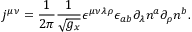<formula> <loc_0><loc_0><loc_500><loc_500>j ^ { \mu \nu } = \frac { 1 } 2 \pi } \frac { 1 } \sqrt { g _ { x } } } \epsilon ^ { \mu \nu \lambda \rho } \epsilon _ { a b } \partial _ { \lambda } n ^ { a } \partial _ { \rho } n ^ { b } .</formula> 